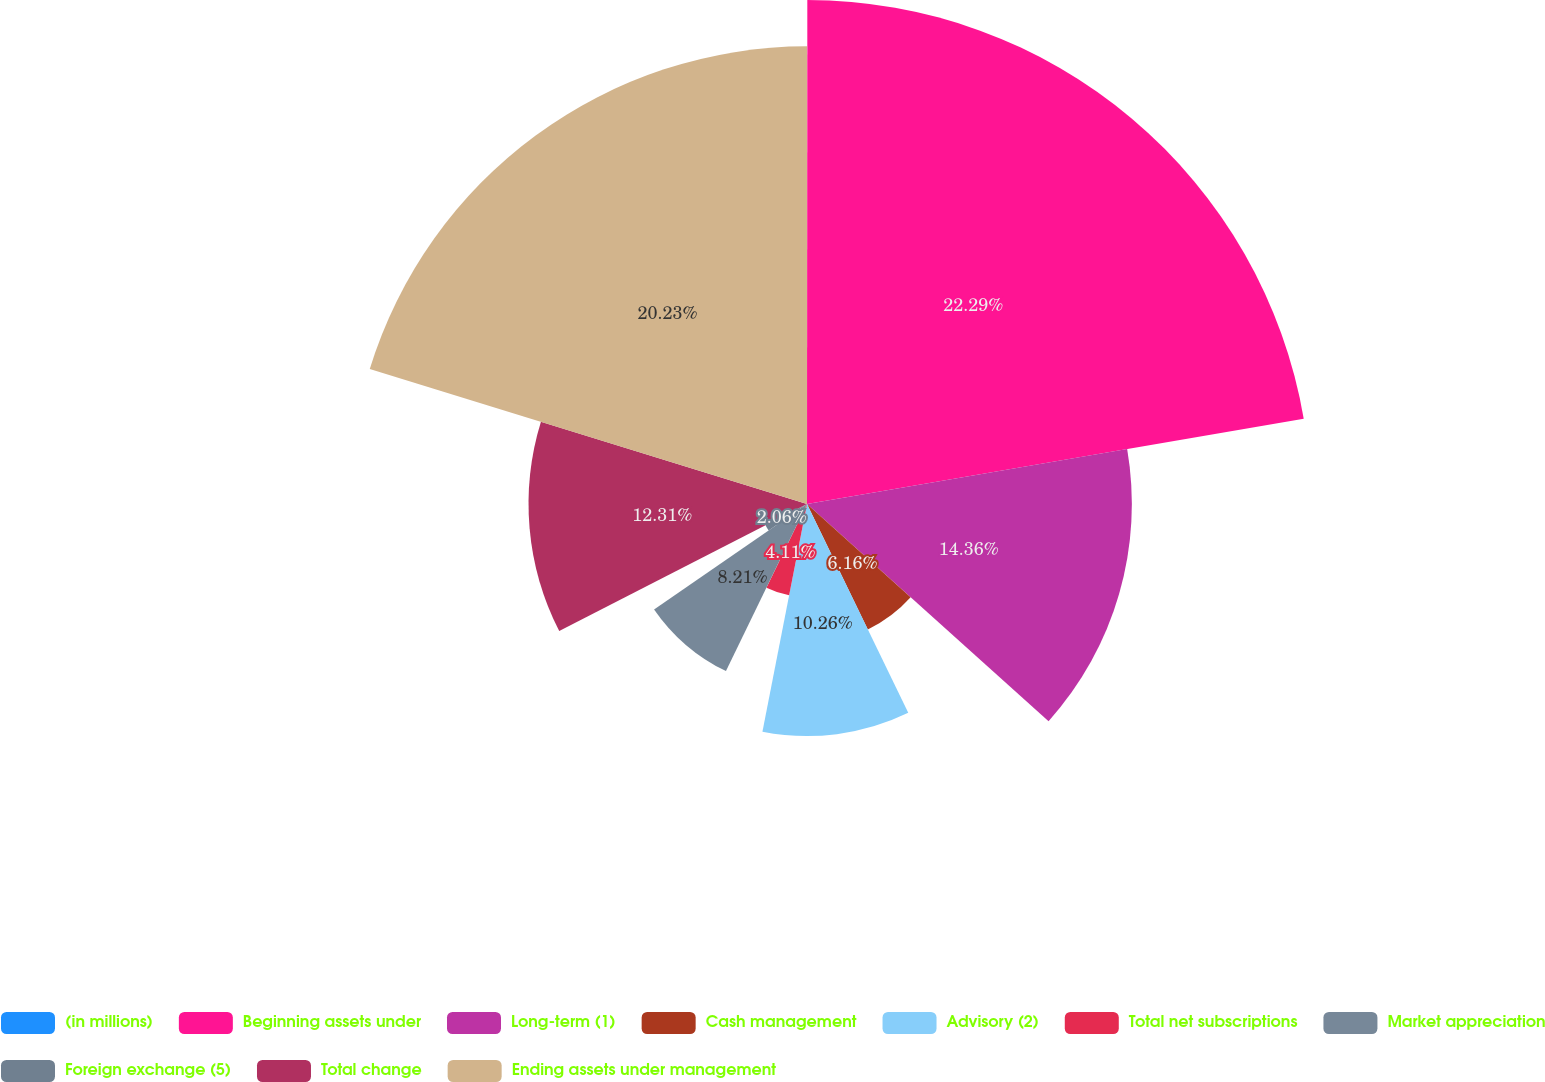Convert chart to OTSL. <chart><loc_0><loc_0><loc_500><loc_500><pie_chart><fcel>(in millions)<fcel>Beginning assets under<fcel>Long-term (1)<fcel>Cash management<fcel>Advisory (2)<fcel>Total net subscriptions<fcel>Market appreciation<fcel>Foreign exchange (5)<fcel>Total change<fcel>Ending assets under management<nl><fcel>0.01%<fcel>22.28%<fcel>14.36%<fcel>6.16%<fcel>10.26%<fcel>4.11%<fcel>8.21%<fcel>2.06%<fcel>12.31%<fcel>20.23%<nl></chart> 